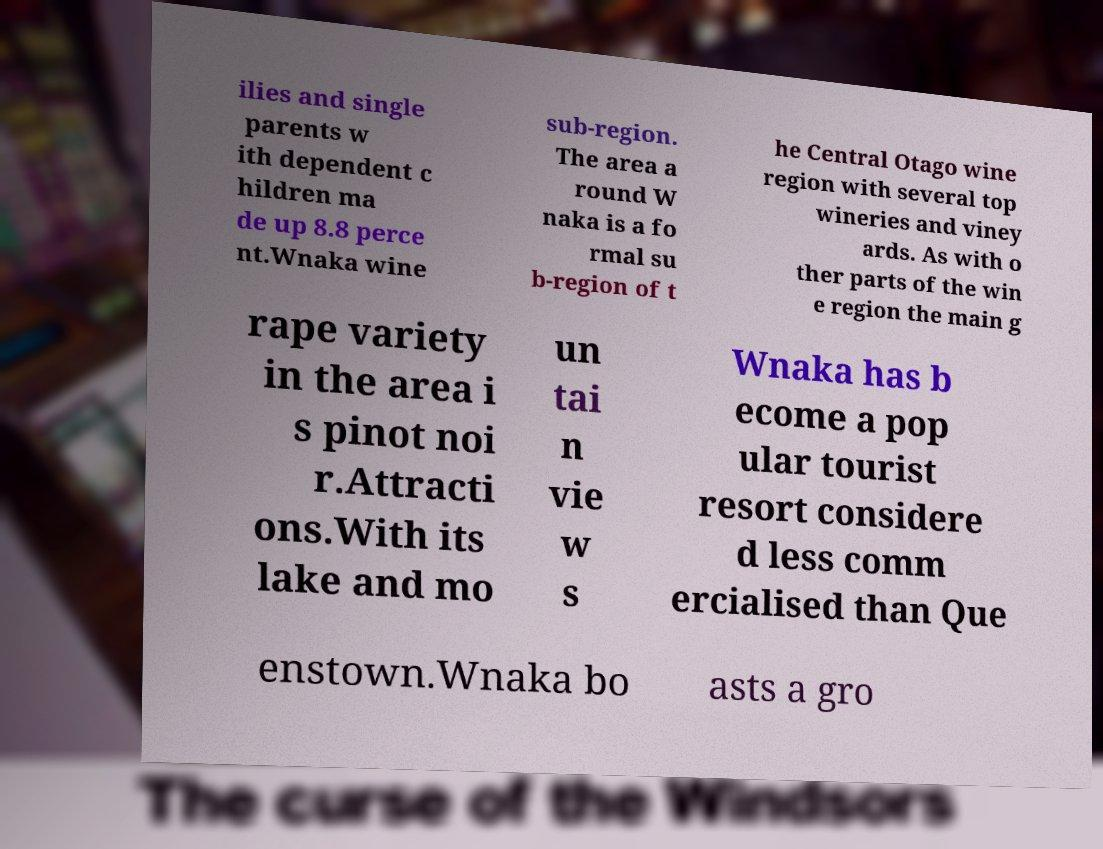There's text embedded in this image that I need extracted. Can you transcribe it verbatim? ilies and single parents w ith dependent c hildren ma de up 8.8 perce nt.Wnaka wine sub-region. The area a round W naka is a fo rmal su b-region of t he Central Otago wine region with several top wineries and viney ards. As with o ther parts of the win e region the main g rape variety in the area i s pinot noi r.Attracti ons.With its lake and mo un tai n vie w s Wnaka has b ecome a pop ular tourist resort considere d less comm ercialised than Que enstown.Wnaka bo asts a gro 